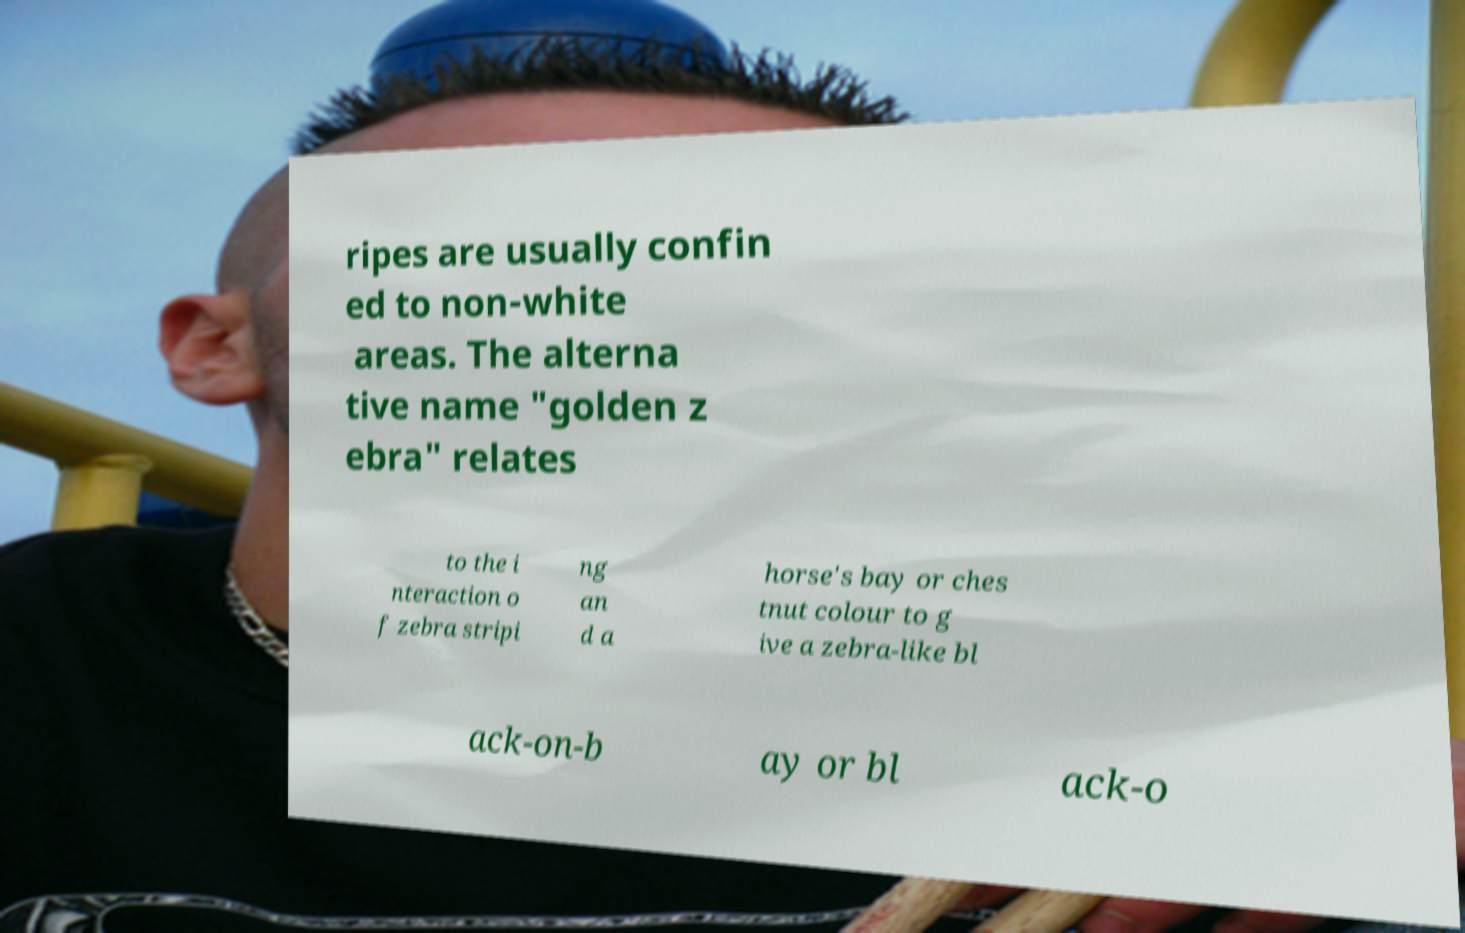Please read and relay the text visible in this image. What does it say? ripes are usually confin ed to non-white areas. The alterna tive name "golden z ebra" relates to the i nteraction o f zebra stripi ng an d a horse's bay or ches tnut colour to g ive a zebra-like bl ack-on-b ay or bl ack-o 